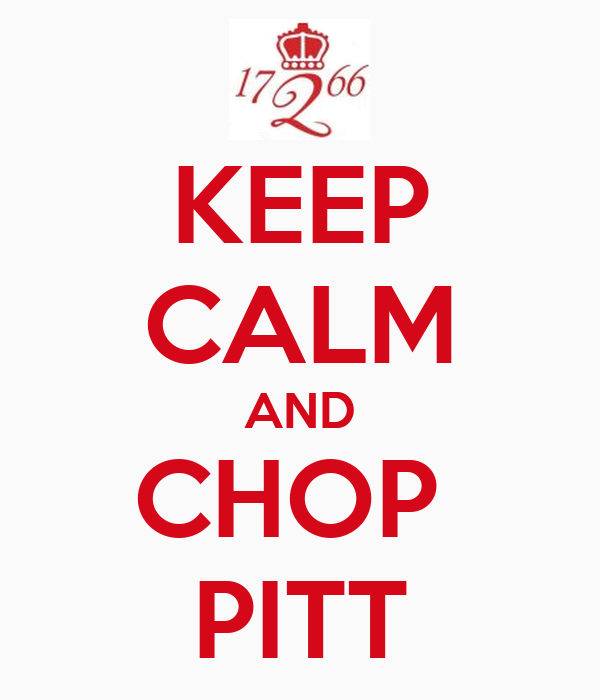Suppose the phrase 'Chop Pitt' is a metaphor in a modern urban setting. What could it represent? In a modern urban setting, the phrase 'Chop Pitt' could metaphorically represent tackling a significant challenge or overcoming obstacles. 'Pitt' might symbolize a difficult situation, a competitive business environment, or a personal adversary. The phrase encourages individuals to stay calm while strategically addressing and 'chopping down' these challenges methodically. As a motivational slogan, it combines traditional wisdom with contemporary relevance, urging people to persevere in the face of adversity. 